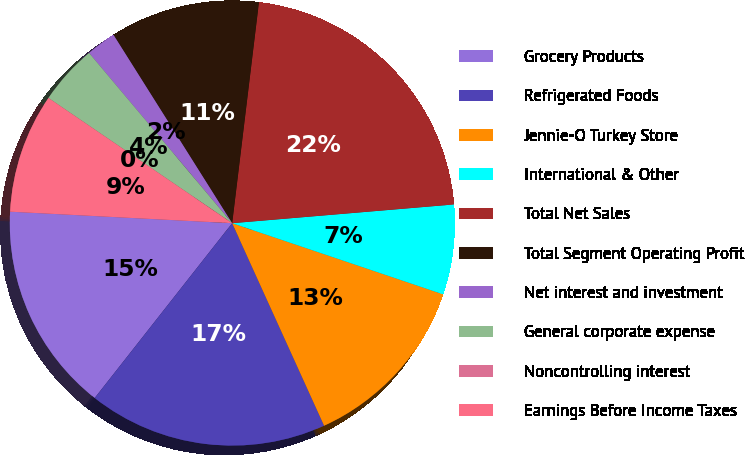<chart> <loc_0><loc_0><loc_500><loc_500><pie_chart><fcel>Grocery Products<fcel>Refrigerated Foods<fcel>Jennie-O Turkey Store<fcel>International & Other<fcel>Total Net Sales<fcel>Total Segment Operating Profit<fcel>Net interest and investment<fcel>General corporate expense<fcel>Noncontrolling interest<fcel>Earnings Before Income Taxes<nl><fcel>15.22%<fcel>17.39%<fcel>13.04%<fcel>6.52%<fcel>21.74%<fcel>10.87%<fcel>2.18%<fcel>4.35%<fcel>0.0%<fcel>8.7%<nl></chart> 